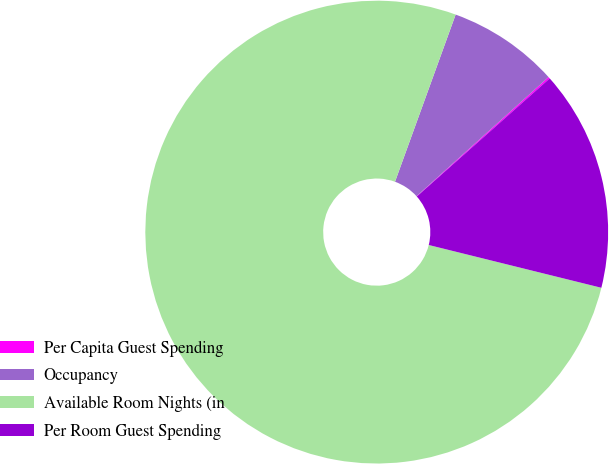Convert chart to OTSL. <chart><loc_0><loc_0><loc_500><loc_500><pie_chart><fcel>Per Capita Guest Spending<fcel>Occupancy<fcel>Available Room Nights (in<fcel>Per Room Guest Spending<nl><fcel>0.12%<fcel>7.78%<fcel>76.67%<fcel>15.43%<nl></chart> 